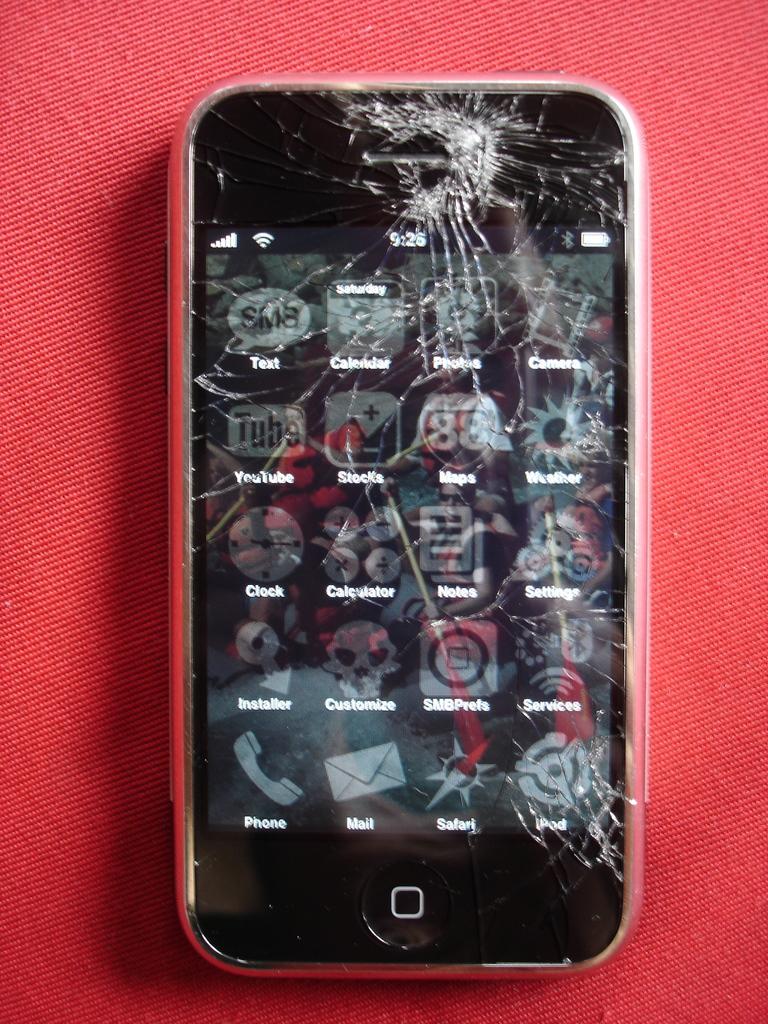What time is on the phone?
Offer a terse response. 9:26. What is the first app on the 2nd row?
Ensure brevity in your answer.  Youtube. 